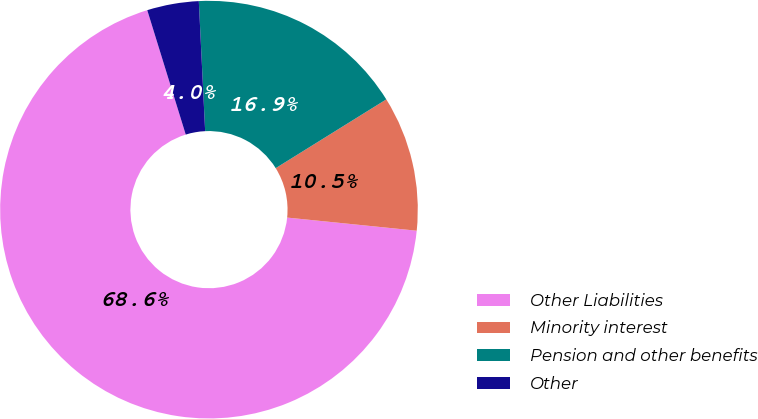Convert chart to OTSL. <chart><loc_0><loc_0><loc_500><loc_500><pie_chart><fcel>Other Liabilities<fcel>Minority interest<fcel>Pension and other benefits<fcel>Other<nl><fcel>68.61%<fcel>10.46%<fcel>16.92%<fcel>4.0%<nl></chart> 